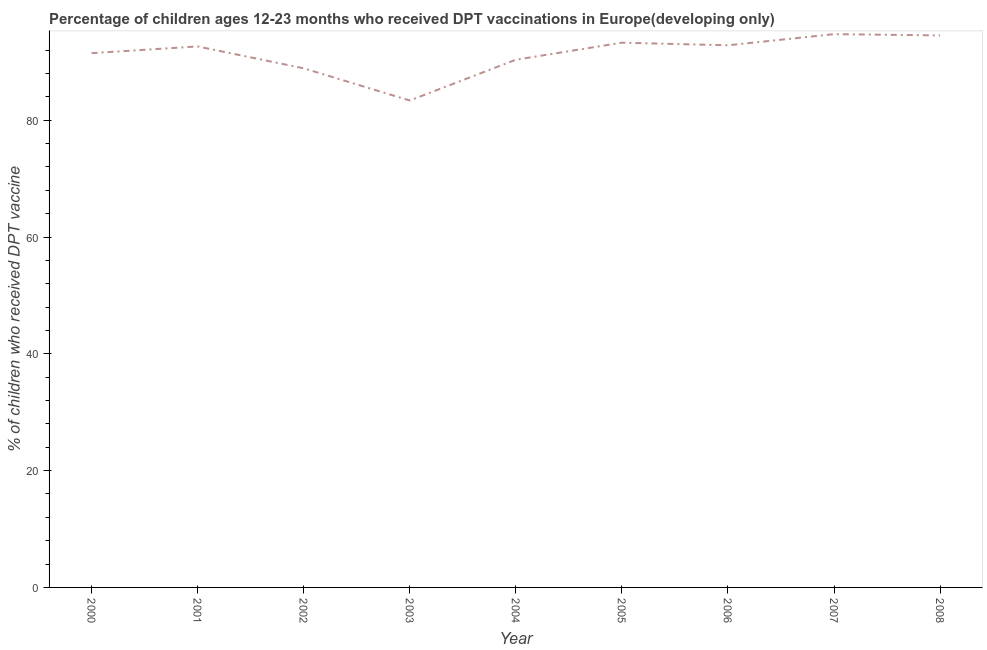What is the percentage of children who received dpt vaccine in 2002?
Your response must be concise. 88.89. Across all years, what is the maximum percentage of children who received dpt vaccine?
Give a very brief answer. 94.73. Across all years, what is the minimum percentage of children who received dpt vaccine?
Your response must be concise. 83.37. In which year was the percentage of children who received dpt vaccine maximum?
Ensure brevity in your answer.  2007. In which year was the percentage of children who received dpt vaccine minimum?
Offer a very short reply. 2003. What is the sum of the percentage of children who received dpt vaccine?
Offer a terse response. 822.07. What is the difference between the percentage of children who received dpt vaccine in 2003 and 2006?
Make the answer very short. -9.45. What is the average percentage of children who received dpt vaccine per year?
Make the answer very short. 91.34. What is the median percentage of children who received dpt vaccine?
Provide a succinct answer. 92.63. In how many years, is the percentage of children who received dpt vaccine greater than 48 %?
Ensure brevity in your answer.  9. Do a majority of the years between 2000 and 2007 (inclusive) have percentage of children who received dpt vaccine greater than 72 %?
Give a very brief answer. Yes. What is the ratio of the percentage of children who received dpt vaccine in 2005 to that in 2008?
Offer a terse response. 0.99. Is the difference between the percentage of children who received dpt vaccine in 2004 and 2005 greater than the difference between any two years?
Ensure brevity in your answer.  No. What is the difference between the highest and the second highest percentage of children who received dpt vaccine?
Ensure brevity in your answer.  0.22. Is the sum of the percentage of children who received dpt vaccine in 2004 and 2006 greater than the maximum percentage of children who received dpt vaccine across all years?
Make the answer very short. Yes. What is the difference between the highest and the lowest percentage of children who received dpt vaccine?
Keep it short and to the point. 11.36. In how many years, is the percentage of children who received dpt vaccine greater than the average percentage of children who received dpt vaccine taken over all years?
Provide a short and direct response. 6. Does the percentage of children who received dpt vaccine monotonically increase over the years?
Keep it short and to the point. No. How many lines are there?
Offer a very short reply. 1. What is the difference between two consecutive major ticks on the Y-axis?
Provide a short and direct response. 20. Are the values on the major ticks of Y-axis written in scientific E-notation?
Offer a very short reply. No. Does the graph contain any zero values?
Ensure brevity in your answer.  No. Does the graph contain grids?
Provide a succinct answer. No. What is the title of the graph?
Offer a very short reply. Percentage of children ages 12-23 months who received DPT vaccinations in Europe(developing only). What is the label or title of the X-axis?
Your answer should be compact. Year. What is the label or title of the Y-axis?
Your answer should be very brief. % of children who received DPT vaccine. What is the % of children who received DPT vaccine of 2000?
Provide a short and direct response. 91.48. What is the % of children who received DPT vaccine in 2001?
Give a very brief answer. 92.63. What is the % of children who received DPT vaccine of 2002?
Provide a short and direct response. 88.89. What is the % of children who received DPT vaccine in 2003?
Your response must be concise. 83.37. What is the % of children who received DPT vaccine in 2004?
Offer a very short reply. 90.35. What is the % of children who received DPT vaccine in 2005?
Your response must be concise. 93.27. What is the % of children who received DPT vaccine of 2006?
Keep it short and to the point. 92.82. What is the % of children who received DPT vaccine in 2007?
Provide a succinct answer. 94.73. What is the % of children who received DPT vaccine in 2008?
Your answer should be very brief. 94.52. What is the difference between the % of children who received DPT vaccine in 2000 and 2001?
Keep it short and to the point. -1.15. What is the difference between the % of children who received DPT vaccine in 2000 and 2002?
Provide a succinct answer. 2.6. What is the difference between the % of children who received DPT vaccine in 2000 and 2003?
Provide a short and direct response. 8.11. What is the difference between the % of children who received DPT vaccine in 2000 and 2004?
Give a very brief answer. 1.13. What is the difference between the % of children who received DPT vaccine in 2000 and 2005?
Your answer should be very brief. -1.79. What is the difference between the % of children who received DPT vaccine in 2000 and 2006?
Your answer should be very brief. -1.34. What is the difference between the % of children who received DPT vaccine in 2000 and 2007?
Keep it short and to the point. -3.25. What is the difference between the % of children who received DPT vaccine in 2000 and 2008?
Offer a terse response. -3.03. What is the difference between the % of children who received DPT vaccine in 2001 and 2002?
Your response must be concise. 3.74. What is the difference between the % of children who received DPT vaccine in 2001 and 2003?
Make the answer very short. 9.26. What is the difference between the % of children who received DPT vaccine in 2001 and 2004?
Ensure brevity in your answer.  2.28. What is the difference between the % of children who received DPT vaccine in 2001 and 2005?
Offer a very short reply. -0.64. What is the difference between the % of children who received DPT vaccine in 2001 and 2006?
Your answer should be compact. -0.2. What is the difference between the % of children who received DPT vaccine in 2001 and 2007?
Provide a succinct answer. -2.11. What is the difference between the % of children who received DPT vaccine in 2001 and 2008?
Provide a succinct answer. -1.89. What is the difference between the % of children who received DPT vaccine in 2002 and 2003?
Give a very brief answer. 5.51. What is the difference between the % of children who received DPT vaccine in 2002 and 2004?
Your answer should be very brief. -1.47. What is the difference between the % of children who received DPT vaccine in 2002 and 2005?
Give a very brief answer. -4.39. What is the difference between the % of children who received DPT vaccine in 2002 and 2006?
Offer a terse response. -3.94. What is the difference between the % of children who received DPT vaccine in 2002 and 2007?
Offer a very short reply. -5.85. What is the difference between the % of children who received DPT vaccine in 2002 and 2008?
Offer a very short reply. -5.63. What is the difference between the % of children who received DPT vaccine in 2003 and 2004?
Make the answer very short. -6.98. What is the difference between the % of children who received DPT vaccine in 2003 and 2005?
Ensure brevity in your answer.  -9.9. What is the difference between the % of children who received DPT vaccine in 2003 and 2006?
Ensure brevity in your answer.  -9.45. What is the difference between the % of children who received DPT vaccine in 2003 and 2007?
Offer a terse response. -11.36. What is the difference between the % of children who received DPT vaccine in 2003 and 2008?
Give a very brief answer. -11.14. What is the difference between the % of children who received DPT vaccine in 2004 and 2005?
Provide a short and direct response. -2.92. What is the difference between the % of children who received DPT vaccine in 2004 and 2006?
Provide a short and direct response. -2.47. What is the difference between the % of children who received DPT vaccine in 2004 and 2007?
Offer a very short reply. -4.38. What is the difference between the % of children who received DPT vaccine in 2004 and 2008?
Your response must be concise. -4.16. What is the difference between the % of children who received DPT vaccine in 2005 and 2006?
Ensure brevity in your answer.  0.45. What is the difference between the % of children who received DPT vaccine in 2005 and 2007?
Provide a short and direct response. -1.46. What is the difference between the % of children who received DPT vaccine in 2005 and 2008?
Your answer should be compact. -1.24. What is the difference between the % of children who received DPT vaccine in 2006 and 2007?
Provide a short and direct response. -1.91. What is the difference between the % of children who received DPT vaccine in 2006 and 2008?
Offer a very short reply. -1.69. What is the difference between the % of children who received DPT vaccine in 2007 and 2008?
Provide a succinct answer. 0.22. What is the ratio of the % of children who received DPT vaccine in 2000 to that in 2003?
Offer a terse response. 1.1. What is the ratio of the % of children who received DPT vaccine in 2000 to that in 2004?
Make the answer very short. 1.01. What is the ratio of the % of children who received DPT vaccine in 2000 to that in 2005?
Keep it short and to the point. 0.98. What is the ratio of the % of children who received DPT vaccine in 2000 to that in 2006?
Offer a terse response. 0.99. What is the ratio of the % of children who received DPT vaccine in 2000 to that in 2007?
Make the answer very short. 0.97. What is the ratio of the % of children who received DPT vaccine in 2000 to that in 2008?
Ensure brevity in your answer.  0.97. What is the ratio of the % of children who received DPT vaccine in 2001 to that in 2002?
Offer a very short reply. 1.04. What is the ratio of the % of children who received DPT vaccine in 2001 to that in 2003?
Offer a very short reply. 1.11. What is the ratio of the % of children who received DPT vaccine in 2001 to that in 2005?
Your response must be concise. 0.99. What is the ratio of the % of children who received DPT vaccine in 2001 to that in 2006?
Provide a short and direct response. 1. What is the ratio of the % of children who received DPT vaccine in 2001 to that in 2007?
Provide a succinct answer. 0.98. What is the ratio of the % of children who received DPT vaccine in 2001 to that in 2008?
Offer a very short reply. 0.98. What is the ratio of the % of children who received DPT vaccine in 2002 to that in 2003?
Provide a succinct answer. 1.07. What is the ratio of the % of children who received DPT vaccine in 2002 to that in 2004?
Your answer should be very brief. 0.98. What is the ratio of the % of children who received DPT vaccine in 2002 to that in 2005?
Your response must be concise. 0.95. What is the ratio of the % of children who received DPT vaccine in 2002 to that in 2006?
Make the answer very short. 0.96. What is the ratio of the % of children who received DPT vaccine in 2002 to that in 2007?
Ensure brevity in your answer.  0.94. What is the ratio of the % of children who received DPT vaccine in 2003 to that in 2004?
Provide a succinct answer. 0.92. What is the ratio of the % of children who received DPT vaccine in 2003 to that in 2005?
Make the answer very short. 0.89. What is the ratio of the % of children who received DPT vaccine in 2003 to that in 2006?
Ensure brevity in your answer.  0.9. What is the ratio of the % of children who received DPT vaccine in 2003 to that in 2008?
Offer a terse response. 0.88. What is the ratio of the % of children who received DPT vaccine in 2004 to that in 2005?
Keep it short and to the point. 0.97. What is the ratio of the % of children who received DPT vaccine in 2004 to that in 2006?
Provide a short and direct response. 0.97. What is the ratio of the % of children who received DPT vaccine in 2004 to that in 2007?
Offer a terse response. 0.95. What is the ratio of the % of children who received DPT vaccine in 2004 to that in 2008?
Make the answer very short. 0.96. What is the ratio of the % of children who received DPT vaccine in 2005 to that in 2006?
Ensure brevity in your answer.  1. What is the ratio of the % of children who received DPT vaccine in 2005 to that in 2007?
Your answer should be very brief. 0.98. What is the ratio of the % of children who received DPT vaccine in 2005 to that in 2008?
Offer a terse response. 0.99. What is the ratio of the % of children who received DPT vaccine in 2006 to that in 2008?
Make the answer very short. 0.98. 